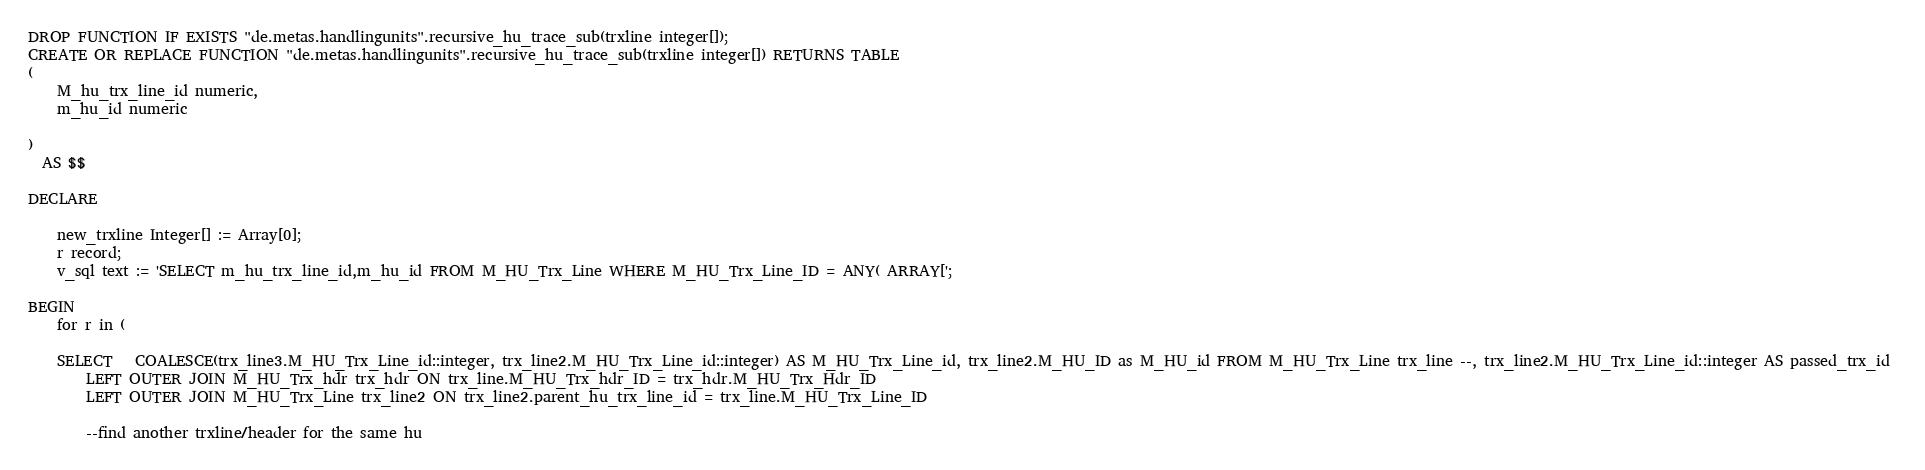Convert code to text. <code><loc_0><loc_0><loc_500><loc_500><_SQL_>DROP FUNCTION IF EXISTS "de.metas.handlingunits".recursive_hu_trace_sub(trxline integer[]);
CREATE OR REPLACE FUNCTION "de.metas.handlingunits".recursive_hu_trace_sub(trxline integer[]) RETURNS TABLE
(
	M_hu_trx_line_id numeric,
	m_hu_id numeric

)
  AS $$
  
DECLARE
  
    new_trxline Integer[] := Array[0];
    r record;
    v_sql text := 'SELECT m_hu_trx_line_id,m_hu_id FROM M_HU_Trx_Line WHERE M_HU_Trx_Line_ID = ANY( ARRAY[';
    
BEGIN
    for r in (
	
	SELECT   COALESCE(trx_line3.M_HU_Trx_Line_id::integer, trx_line2.M_HU_Trx_Line_id::integer) AS M_HU_Trx_Line_id, trx_line2.M_HU_ID as M_HU_id FROM M_HU_Trx_Line trx_line --, trx_line2.M_HU_Trx_Line_id::integer AS passed_trx_id 
		LEFT OUTER JOIN M_HU_Trx_hdr trx_hdr ON trx_line.M_HU_Trx_hdr_ID = trx_hdr.M_HU_Trx_Hdr_ID
		LEFT OUTER JOIN M_HU_Trx_Line trx_line2 ON trx_line2.parent_hu_trx_line_id = trx_line.M_HU_Trx_Line_ID
			
		--find another trxline/header for the same hu</code> 